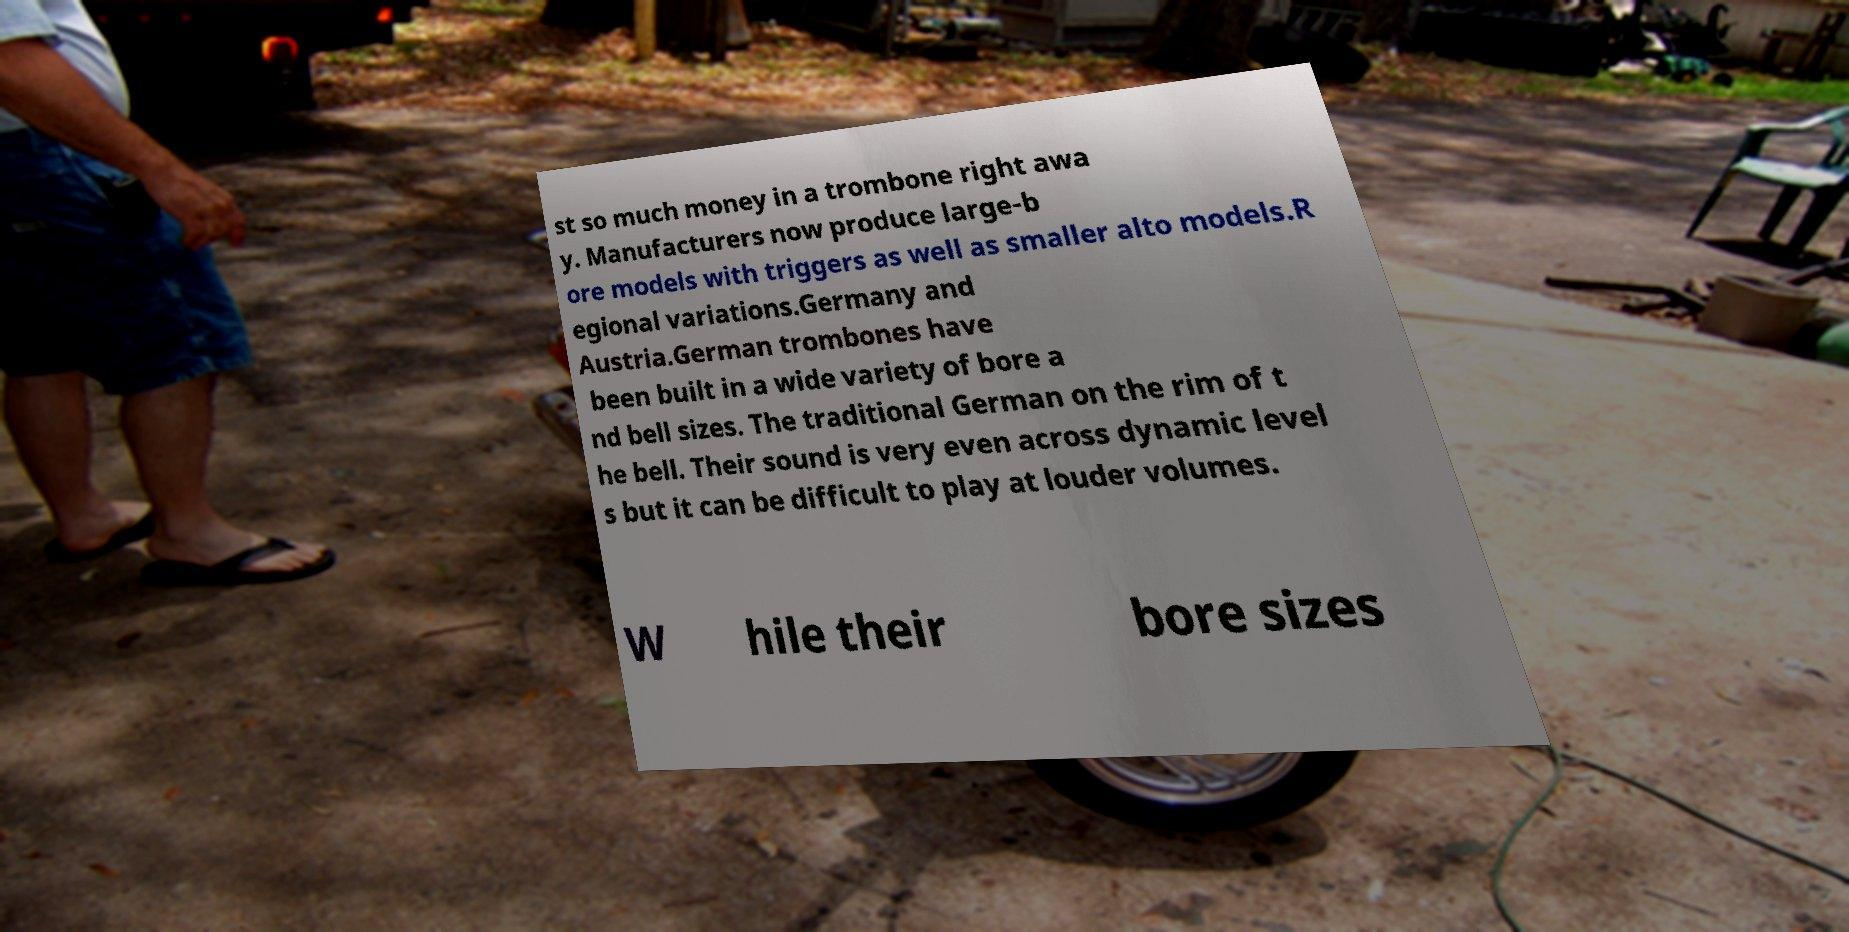Could you assist in decoding the text presented in this image and type it out clearly? st so much money in a trombone right awa y. Manufacturers now produce large-b ore models with triggers as well as smaller alto models.R egional variations.Germany and Austria.German trombones have been built in a wide variety of bore a nd bell sizes. The traditional German on the rim of t he bell. Their sound is very even across dynamic level s but it can be difficult to play at louder volumes. W hile their bore sizes 